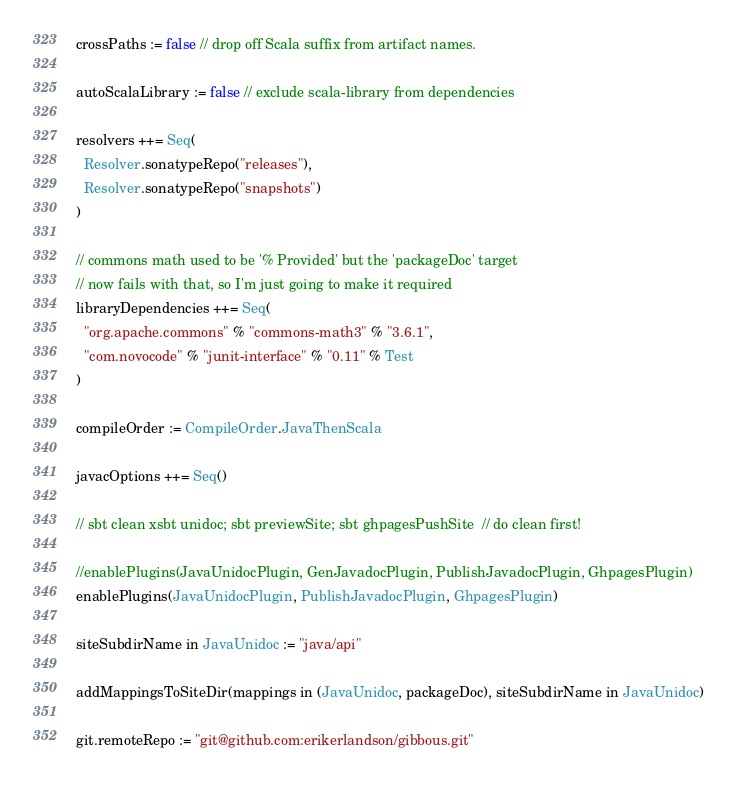Convert code to text. <code><loc_0><loc_0><loc_500><loc_500><_Scala_>
crossPaths := false // drop off Scala suffix from artifact names.

autoScalaLibrary := false // exclude scala-library from dependencies

resolvers ++= Seq(
  Resolver.sonatypeRepo("releases"),
  Resolver.sonatypeRepo("snapshots")
)

// commons math used to be '% Provided' but the 'packageDoc' target
// now fails with that, so I'm just going to make it required
libraryDependencies ++= Seq(
  "org.apache.commons" % "commons-math3" % "3.6.1",
  "com.novocode" % "junit-interface" % "0.11" % Test
)

compileOrder := CompileOrder.JavaThenScala

javacOptions ++= Seq()

// sbt clean xsbt unidoc; sbt previewSite; sbt ghpagesPushSite  // do clean first!

//enablePlugins(JavaUnidocPlugin, GenJavadocPlugin, PublishJavadocPlugin, GhpagesPlugin)
enablePlugins(JavaUnidocPlugin, PublishJavadocPlugin, GhpagesPlugin)

siteSubdirName in JavaUnidoc := "java/api"

addMappingsToSiteDir(mappings in (JavaUnidoc, packageDoc), siteSubdirName in JavaUnidoc)

git.remoteRepo := "git@github.com:erikerlandson/gibbous.git"
</code> 